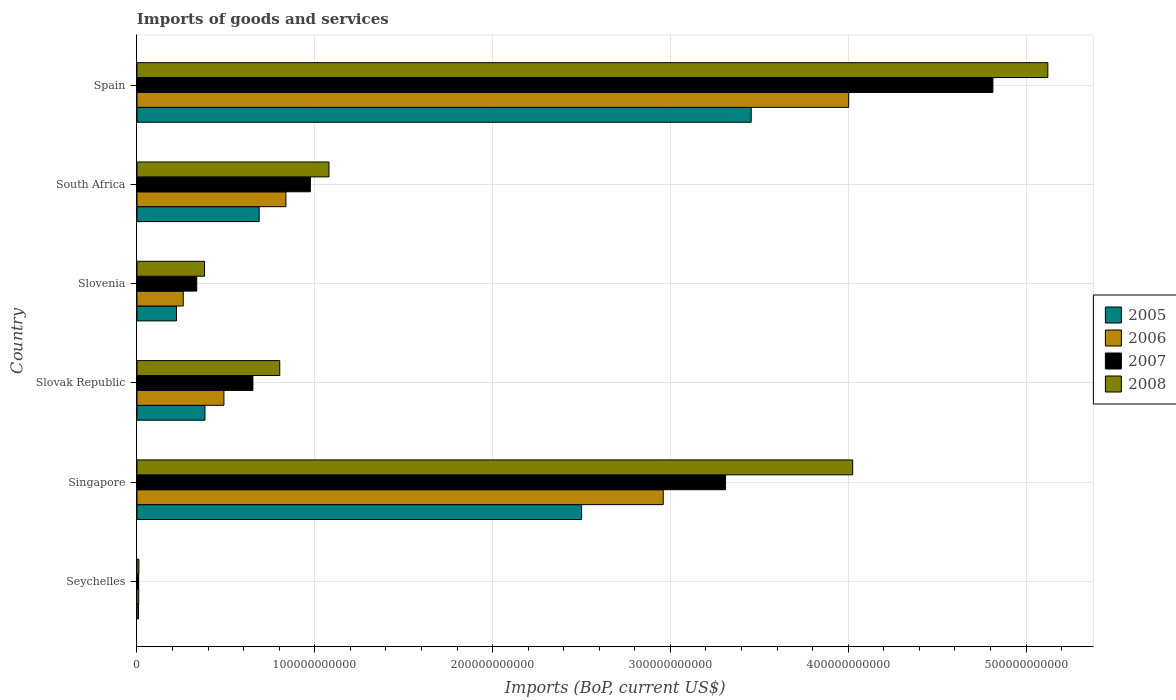How many bars are there on the 5th tick from the bottom?
Offer a very short reply. 4. What is the label of the 5th group of bars from the top?
Provide a succinct answer. Singapore. In how many cases, is the number of bars for a given country not equal to the number of legend labels?
Provide a succinct answer. 0. What is the amount spent on imports in 2005 in Singapore?
Provide a succinct answer. 2.50e+11. Across all countries, what is the maximum amount spent on imports in 2008?
Give a very brief answer. 5.12e+11. Across all countries, what is the minimum amount spent on imports in 2008?
Offer a terse response. 1.08e+09. In which country was the amount spent on imports in 2006 maximum?
Give a very brief answer. Spain. In which country was the amount spent on imports in 2005 minimum?
Provide a succinct answer. Seychelles. What is the total amount spent on imports in 2007 in the graph?
Offer a terse response. 1.01e+12. What is the difference between the amount spent on imports in 2006 in Seychelles and that in Slovak Republic?
Make the answer very short. -4.79e+1. What is the difference between the amount spent on imports in 2007 in Seychelles and the amount spent on imports in 2006 in Slovak Republic?
Keep it short and to the point. -4.80e+1. What is the average amount spent on imports in 2008 per country?
Your response must be concise. 1.90e+11. What is the difference between the amount spent on imports in 2006 and amount spent on imports in 2007 in Spain?
Offer a very short reply. -8.11e+1. What is the ratio of the amount spent on imports in 2005 in Singapore to that in Slovak Republic?
Your answer should be compact. 6.54. What is the difference between the highest and the second highest amount spent on imports in 2006?
Offer a very short reply. 1.04e+11. What is the difference between the highest and the lowest amount spent on imports in 2008?
Offer a very short reply. 5.11e+11. Is the sum of the amount spent on imports in 2007 in Slovak Republic and South Africa greater than the maximum amount spent on imports in 2005 across all countries?
Ensure brevity in your answer.  No. Is it the case that in every country, the sum of the amount spent on imports in 2005 and amount spent on imports in 2007 is greater than the sum of amount spent on imports in 2008 and amount spent on imports in 2006?
Ensure brevity in your answer.  No. What does the 1st bar from the top in Seychelles represents?
Ensure brevity in your answer.  2008. What does the 3rd bar from the bottom in Seychelles represents?
Ensure brevity in your answer.  2007. Is it the case that in every country, the sum of the amount spent on imports in 2007 and amount spent on imports in 2008 is greater than the amount spent on imports in 2005?
Your answer should be very brief. Yes. How many bars are there?
Keep it short and to the point. 24. Are all the bars in the graph horizontal?
Keep it short and to the point. Yes. How many countries are there in the graph?
Give a very brief answer. 6. What is the difference between two consecutive major ticks on the X-axis?
Provide a short and direct response. 1.00e+11. Does the graph contain any zero values?
Your response must be concise. No. Does the graph contain grids?
Provide a succinct answer. Yes. How many legend labels are there?
Give a very brief answer. 4. What is the title of the graph?
Provide a short and direct response. Imports of goods and services. What is the label or title of the X-axis?
Make the answer very short. Imports (BoP, current US$). What is the Imports (BoP, current US$) of 2005 in Seychelles?
Offer a very short reply. 8.85e+08. What is the Imports (BoP, current US$) in 2006 in Seychelles?
Provide a short and direct response. 9.85e+08. What is the Imports (BoP, current US$) in 2007 in Seychelles?
Ensure brevity in your answer.  9.49e+08. What is the Imports (BoP, current US$) in 2008 in Seychelles?
Ensure brevity in your answer.  1.08e+09. What is the Imports (BoP, current US$) of 2005 in Singapore?
Give a very brief answer. 2.50e+11. What is the Imports (BoP, current US$) of 2006 in Singapore?
Offer a very short reply. 2.96e+11. What is the Imports (BoP, current US$) of 2007 in Singapore?
Ensure brevity in your answer.  3.31e+11. What is the Imports (BoP, current US$) of 2008 in Singapore?
Offer a very short reply. 4.03e+11. What is the Imports (BoP, current US$) of 2005 in Slovak Republic?
Your answer should be compact. 3.82e+1. What is the Imports (BoP, current US$) in 2006 in Slovak Republic?
Keep it short and to the point. 4.89e+1. What is the Imports (BoP, current US$) in 2007 in Slovak Republic?
Offer a very short reply. 6.52e+1. What is the Imports (BoP, current US$) of 2008 in Slovak Republic?
Give a very brief answer. 8.03e+1. What is the Imports (BoP, current US$) in 2005 in Slovenia?
Make the answer very short. 2.22e+1. What is the Imports (BoP, current US$) of 2006 in Slovenia?
Your answer should be very brief. 2.60e+1. What is the Imports (BoP, current US$) in 2007 in Slovenia?
Your answer should be compact. 3.36e+1. What is the Imports (BoP, current US$) in 2008 in Slovenia?
Your answer should be very brief. 3.80e+1. What is the Imports (BoP, current US$) in 2005 in South Africa?
Make the answer very short. 6.87e+1. What is the Imports (BoP, current US$) in 2006 in South Africa?
Your answer should be compact. 8.38e+1. What is the Imports (BoP, current US$) in 2007 in South Africa?
Your response must be concise. 9.75e+1. What is the Imports (BoP, current US$) in 2008 in South Africa?
Make the answer very short. 1.08e+11. What is the Imports (BoP, current US$) in 2005 in Spain?
Your answer should be very brief. 3.45e+11. What is the Imports (BoP, current US$) of 2006 in Spain?
Make the answer very short. 4.00e+11. What is the Imports (BoP, current US$) of 2007 in Spain?
Ensure brevity in your answer.  4.81e+11. What is the Imports (BoP, current US$) in 2008 in Spain?
Your answer should be very brief. 5.12e+11. Across all countries, what is the maximum Imports (BoP, current US$) of 2005?
Make the answer very short. 3.45e+11. Across all countries, what is the maximum Imports (BoP, current US$) of 2006?
Give a very brief answer. 4.00e+11. Across all countries, what is the maximum Imports (BoP, current US$) of 2007?
Give a very brief answer. 4.81e+11. Across all countries, what is the maximum Imports (BoP, current US$) in 2008?
Give a very brief answer. 5.12e+11. Across all countries, what is the minimum Imports (BoP, current US$) of 2005?
Offer a very short reply. 8.85e+08. Across all countries, what is the minimum Imports (BoP, current US$) of 2006?
Offer a very short reply. 9.85e+08. Across all countries, what is the minimum Imports (BoP, current US$) of 2007?
Provide a short and direct response. 9.49e+08. Across all countries, what is the minimum Imports (BoP, current US$) in 2008?
Ensure brevity in your answer.  1.08e+09. What is the total Imports (BoP, current US$) in 2005 in the graph?
Provide a short and direct response. 7.26e+11. What is the total Imports (BoP, current US$) of 2006 in the graph?
Ensure brevity in your answer.  8.56e+11. What is the total Imports (BoP, current US$) in 2007 in the graph?
Your answer should be very brief. 1.01e+12. What is the total Imports (BoP, current US$) of 2008 in the graph?
Your answer should be very brief. 1.14e+12. What is the difference between the Imports (BoP, current US$) of 2005 in Seychelles and that in Singapore?
Your response must be concise. -2.49e+11. What is the difference between the Imports (BoP, current US$) in 2006 in Seychelles and that in Singapore?
Your answer should be very brief. -2.95e+11. What is the difference between the Imports (BoP, current US$) of 2007 in Seychelles and that in Singapore?
Offer a very short reply. -3.30e+11. What is the difference between the Imports (BoP, current US$) of 2008 in Seychelles and that in Singapore?
Keep it short and to the point. -4.01e+11. What is the difference between the Imports (BoP, current US$) in 2005 in Seychelles and that in Slovak Republic?
Make the answer very short. -3.74e+1. What is the difference between the Imports (BoP, current US$) in 2006 in Seychelles and that in Slovak Republic?
Your response must be concise. -4.79e+1. What is the difference between the Imports (BoP, current US$) in 2007 in Seychelles and that in Slovak Republic?
Ensure brevity in your answer.  -6.43e+1. What is the difference between the Imports (BoP, current US$) in 2008 in Seychelles and that in Slovak Republic?
Give a very brief answer. -7.92e+1. What is the difference between the Imports (BoP, current US$) in 2005 in Seychelles and that in Slovenia?
Give a very brief answer. -2.14e+1. What is the difference between the Imports (BoP, current US$) of 2006 in Seychelles and that in Slovenia?
Provide a short and direct response. -2.51e+1. What is the difference between the Imports (BoP, current US$) of 2007 in Seychelles and that in Slovenia?
Provide a succinct answer. -3.27e+1. What is the difference between the Imports (BoP, current US$) of 2008 in Seychelles and that in Slovenia?
Your response must be concise. -3.69e+1. What is the difference between the Imports (BoP, current US$) of 2005 in Seychelles and that in South Africa?
Your answer should be compact. -6.78e+1. What is the difference between the Imports (BoP, current US$) of 2006 in Seychelles and that in South Africa?
Your answer should be compact. -8.28e+1. What is the difference between the Imports (BoP, current US$) in 2007 in Seychelles and that in South Africa?
Your answer should be very brief. -9.66e+1. What is the difference between the Imports (BoP, current US$) in 2008 in Seychelles and that in South Africa?
Offer a very short reply. -1.07e+11. What is the difference between the Imports (BoP, current US$) in 2005 in Seychelles and that in Spain?
Your answer should be very brief. -3.45e+11. What is the difference between the Imports (BoP, current US$) in 2006 in Seychelles and that in Spain?
Your answer should be very brief. -3.99e+11. What is the difference between the Imports (BoP, current US$) of 2007 in Seychelles and that in Spain?
Your answer should be compact. -4.80e+11. What is the difference between the Imports (BoP, current US$) in 2008 in Seychelles and that in Spain?
Provide a short and direct response. -5.11e+11. What is the difference between the Imports (BoP, current US$) in 2005 in Singapore and that in Slovak Republic?
Your response must be concise. 2.12e+11. What is the difference between the Imports (BoP, current US$) in 2006 in Singapore and that in Slovak Republic?
Offer a very short reply. 2.47e+11. What is the difference between the Imports (BoP, current US$) in 2007 in Singapore and that in Slovak Republic?
Offer a terse response. 2.66e+11. What is the difference between the Imports (BoP, current US$) in 2008 in Singapore and that in Slovak Republic?
Your answer should be compact. 3.22e+11. What is the difference between the Imports (BoP, current US$) in 2005 in Singapore and that in Slovenia?
Your answer should be compact. 2.28e+11. What is the difference between the Imports (BoP, current US$) of 2006 in Singapore and that in Slovenia?
Give a very brief answer. 2.70e+11. What is the difference between the Imports (BoP, current US$) in 2007 in Singapore and that in Slovenia?
Provide a short and direct response. 2.97e+11. What is the difference between the Imports (BoP, current US$) in 2008 in Singapore and that in Slovenia?
Provide a succinct answer. 3.64e+11. What is the difference between the Imports (BoP, current US$) of 2005 in Singapore and that in South Africa?
Keep it short and to the point. 1.81e+11. What is the difference between the Imports (BoP, current US$) in 2006 in Singapore and that in South Africa?
Provide a succinct answer. 2.12e+11. What is the difference between the Imports (BoP, current US$) in 2007 in Singapore and that in South Africa?
Provide a succinct answer. 2.34e+11. What is the difference between the Imports (BoP, current US$) of 2008 in Singapore and that in South Africa?
Provide a succinct answer. 2.95e+11. What is the difference between the Imports (BoP, current US$) of 2005 in Singapore and that in Spain?
Provide a short and direct response. -9.54e+1. What is the difference between the Imports (BoP, current US$) of 2006 in Singapore and that in Spain?
Provide a short and direct response. -1.04e+11. What is the difference between the Imports (BoP, current US$) of 2007 in Singapore and that in Spain?
Your answer should be very brief. -1.50e+11. What is the difference between the Imports (BoP, current US$) of 2008 in Singapore and that in Spain?
Offer a very short reply. -1.10e+11. What is the difference between the Imports (BoP, current US$) of 2005 in Slovak Republic and that in Slovenia?
Your answer should be compact. 1.60e+1. What is the difference between the Imports (BoP, current US$) of 2006 in Slovak Republic and that in Slovenia?
Provide a succinct answer. 2.29e+1. What is the difference between the Imports (BoP, current US$) of 2007 in Slovak Republic and that in Slovenia?
Offer a terse response. 3.16e+1. What is the difference between the Imports (BoP, current US$) in 2008 in Slovak Republic and that in Slovenia?
Provide a succinct answer. 4.23e+1. What is the difference between the Imports (BoP, current US$) in 2005 in Slovak Republic and that in South Africa?
Your answer should be compact. -3.05e+1. What is the difference between the Imports (BoP, current US$) in 2006 in Slovak Republic and that in South Africa?
Your response must be concise. -3.49e+1. What is the difference between the Imports (BoP, current US$) of 2007 in Slovak Republic and that in South Africa?
Your response must be concise. -3.23e+1. What is the difference between the Imports (BoP, current US$) in 2008 in Slovak Republic and that in South Africa?
Ensure brevity in your answer.  -2.77e+1. What is the difference between the Imports (BoP, current US$) in 2005 in Slovak Republic and that in Spain?
Your response must be concise. -3.07e+11. What is the difference between the Imports (BoP, current US$) in 2006 in Slovak Republic and that in Spain?
Your answer should be very brief. -3.51e+11. What is the difference between the Imports (BoP, current US$) in 2007 in Slovak Republic and that in Spain?
Ensure brevity in your answer.  -4.16e+11. What is the difference between the Imports (BoP, current US$) in 2008 in Slovak Republic and that in Spain?
Make the answer very short. -4.32e+11. What is the difference between the Imports (BoP, current US$) in 2005 in Slovenia and that in South Africa?
Offer a terse response. -4.65e+1. What is the difference between the Imports (BoP, current US$) of 2006 in Slovenia and that in South Africa?
Ensure brevity in your answer.  -5.77e+1. What is the difference between the Imports (BoP, current US$) of 2007 in Slovenia and that in South Africa?
Keep it short and to the point. -6.39e+1. What is the difference between the Imports (BoP, current US$) of 2008 in Slovenia and that in South Africa?
Offer a very short reply. -7.00e+1. What is the difference between the Imports (BoP, current US$) in 2005 in Slovenia and that in Spain?
Keep it short and to the point. -3.23e+11. What is the difference between the Imports (BoP, current US$) in 2006 in Slovenia and that in Spain?
Your answer should be compact. -3.74e+11. What is the difference between the Imports (BoP, current US$) of 2007 in Slovenia and that in Spain?
Provide a succinct answer. -4.48e+11. What is the difference between the Imports (BoP, current US$) in 2008 in Slovenia and that in Spain?
Offer a terse response. -4.74e+11. What is the difference between the Imports (BoP, current US$) in 2005 in South Africa and that in Spain?
Give a very brief answer. -2.77e+11. What is the difference between the Imports (BoP, current US$) of 2006 in South Africa and that in Spain?
Your response must be concise. -3.16e+11. What is the difference between the Imports (BoP, current US$) in 2007 in South Africa and that in Spain?
Your answer should be compact. -3.84e+11. What is the difference between the Imports (BoP, current US$) of 2008 in South Africa and that in Spain?
Provide a short and direct response. -4.04e+11. What is the difference between the Imports (BoP, current US$) of 2005 in Seychelles and the Imports (BoP, current US$) of 2006 in Singapore?
Offer a very short reply. -2.95e+11. What is the difference between the Imports (BoP, current US$) of 2005 in Seychelles and the Imports (BoP, current US$) of 2007 in Singapore?
Offer a very short reply. -3.30e+11. What is the difference between the Imports (BoP, current US$) of 2005 in Seychelles and the Imports (BoP, current US$) of 2008 in Singapore?
Provide a short and direct response. -4.02e+11. What is the difference between the Imports (BoP, current US$) of 2006 in Seychelles and the Imports (BoP, current US$) of 2007 in Singapore?
Your answer should be very brief. -3.30e+11. What is the difference between the Imports (BoP, current US$) in 2006 in Seychelles and the Imports (BoP, current US$) in 2008 in Singapore?
Ensure brevity in your answer.  -4.02e+11. What is the difference between the Imports (BoP, current US$) in 2007 in Seychelles and the Imports (BoP, current US$) in 2008 in Singapore?
Provide a short and direct response. -4.02e+11. What is the difference between the Imports (BoP, current US$) in 2005 in Seychelles and the Imports (BoP, current US$) in 2006 in Slovak Republic?
Your response must be concise. -4.80e+1. What is the difference between the Imports (BoP, current US$) in 2005 in Seychelles and the Imports (BoP, current US$) in 2007 in Slovak Republic?
Make the answer very short. -6.43e+1. What is the difference between the Imports (BoP, current US$) in 2005 in Seychelles and the Imports (BoP, current US$) in 2008 in Slovak Republic?
Your response must be concise. -7.94e+1. What is the difference between the Imports (BoP, current US$) in 2006 in Seychelles and the Imports (BoP, current US$) in 2007 in Slovak Republic?
Give a very brief answer. -6.42e+1. What is the difference between the Imports (BoP, current US$) in 2006 in Seychelles and the Imports (BoP, current US$) in 2008 in Slovak Republic?
Give a very brief answer. -7.93e+1. What is the difference between the Imports (BoP, current US$) in 2007 in Seychelles and the Imports (BoP, current US$) in 2008 in Slovak Republic?
Give a very brief answer. -7.93e+1. What is the difference between the Imports (BoP, current US$) in 2005 in Seychelles and the Imports (BoP, current US$) in 2006 in Slovenia?
Provide a short and direct response. -2.52e+1. What is the difference between the Imports (BoP, current US$) of 2005 in Seychelles and the Imports (BoP, current US$) of 2007 in Slovenia?
Ensure brevity in your answer.  -3.27e+1. What is the difference between the Imports (BoP, current US$) in 2005 in Seychelles and the Imports (BoP, current US$) in 2008 in Slovenia?
Your answer should be very brief. -3.71e+1. What is the difference between the Imports (BoP, current US$) in 2006 in Seychelles and the Imports (BoP, current US$) in 2007 in Slovenia?
Make the answer very short. -3.26e+1. What is the difference between the Imports (BoP, current US$) of 2006 in Seychelles and the Imports (BoP, current US$) of 2008 in Slovenia?
Your response must be concise. -3.70e+1. What is the difference between the Imports (BoP, current US$) in 2007 in Seychelles and the Imports (BoP, current US$) in 2008 in Slovenia?
Make the answer very short. -3.71e+1. What is the difference between the Imports (BoP, current US$) of 2005 in Seychelles and the Imports (BoP, current US$) of 2006 in South Africa?
Ensure brevity in your answer.  -8.29e+1. What is the difference between the Imports (BoP, current US$) of 2005 in Seychelles and the Imports (BoP, current US$) of 2007 in South Africa?
Your answer should be compact. -9.66e+1. What is the difference between the Imports (BoP, current US$) of 2005 in Seychelles and the Imports (BoP, current US$) of 2008 in South Africa?
Offer a terse response. -1.07e+11. What is the difference between the Imports (BoP, current US$) in 2006 in Seychelles and the Imports (BoP, current US$) in 2007 in South Africa?
Your response must be concise. -9.65e+1. What is the difference between the Imports (BoP, current US$) in 2006 in Seychelles and the Imports (BoP, current US$) in 2008 in South Africa?
Keep it short and to the point. -1.07e+11. What is the difference between the Imports (BoP, current US$) in 2007 in Seychelles and the Imports (BoP, current US$) in 2008 in South Africa?
Offer a very short reply. -1.07e+11. What is the difference between the Imports (BoP, current US$) in 2005 in Seychelles and the Imports (BoP, current US$) in 2006 in Spain?
Offer a very short reply. -3.99e+11. What is the difference between the Imports (BoP, current US$) of 2005 in Seychelles and the Imports (BoP, current US$) of 2007 in Spain?
Make the answer very short. -4.80e+11. What is the difference between the Imports (BoP, current US$) in 2005 in Seychelles and the Imports (BoP, current US$) in 2008 in Spain?
Offer a terse response. -5.11e+11. What is the difference between the Imports (BoP, current US$) of 2006 in Seychelles and the Imports (BoP, current US$) of 2007 in Spain?
Make the answer very short. -4.80e+11. What is the difference between the Imports (BoP, current US$) in 2006 in Seychelles and the Imports (BoP, current US$) in 2008 in Spain?
Provide a succinct answer. -5.11e+11. What is the difference between the Imports (BoP, current US$) in 2007 in Seychelles and the Imports (BoP, current US$) in 2008 in Spain?
Your answer should be compact. -5.11e+11. What is the difference between the Imports (BoP, current US$) of 2005 in Singapore and the Imports (BoP, current US$) of 2006 in Slovak Republic?
Give a very brief answer. 2.01e+11. What is the difference between the Imports (BoP, current US$) of 2005 in Singapore and the Imports (BoP, current US$) of 2007 in Slovak Republic?
Your response must be concise. 1.85e+11. What is the difference between the Imports (BoP, current US$) in 2005 in Singapore and the Imports (BoP, current US$) in 2008 in Slovak Republic?
Offer a terse response. 1.70e+11. What is the difference between the Imports (BoP, current US$) of 2006 in Singapore and the Imports (BoP, current US$) of 2007 in Slovak Republic?
Offer a terse response. 2.31e+11. What is the difference between the Imports (BoP, current US$) in 2006 in Singapore and the Imports (BoP, current US$) in 2008 in Slovak Republic?
Offer a very short reply. 2.16e+11. What is the difference between the Imports (BoP, current US$) in 2007 in Singapore and the Imports (BoP, current US$) in 2008 in Slovak Republic?
Your response must be concise. 2.51e+11. What is the difference between the Imports (BoP, current US$) in 2005 in Singapore and the Imports (BoP, current US$) in 2006 in Slovenia?
Keep it short and to the point. 2.24e+11. What is the difference between the Imports (BoP, current US$) of 2005 in Singapore and the Imports (BoP, current US$) of 2007 in Slovenia?
Provide a short and direct response. 2.16e+11. What is the difference between the Imports (BoP, current US$) in 2005 in Singapore and the Imports (BoP, current US$) in 2008 in Slovenia?
Keep it short and to the point. 2.12e+11. What is the difference between the Imports (BoP, current US$) of 2006 in Singapore and the Imports (BoP, current US$) of 2007 in Slovenia?
Offer a terse response. 2.62e+11. What is the difference between the Imports (BoP, current US$) of 2006 in Singapore and the Imports (BoP, current US$) of 2008 in Slovenia?
Offer a terse response. 2.58e+11. What is the difference between the Imports (BoP, current US$) in 2007 in Singapore and the Imports (BoP, current US$) in 2008 in Slovenia?
Your response must be concise. 2.93e+11. What is the difference between the Imports (BoP, current US$) in 2005 in Singapore and the Imports (BoP, current US$) in 2006 in South Africa?
Offer a very short reply. 1.66e+11. What is the difference between the Imports (BoP, current US$) in 2005 in Singapore and the Imports (BoP, current US$) in 2007 in South Africa?
Offer a terse response. 1.53e+11. What is the difference between the Imports (BoP, current US$) in 2005 in Singapore and the Imports (BoP, current US$) in 2008 in South Africa?
Your response must be concise. 1.42e+11. What is the difference between the Imports (BoP, current US$) of 2006 in Singapore and the Imports (BoP, current US$) of 2007 in South Africa?
Offer a terse response. 1.98e+11. What is the difference between the Imports (BoP, current US$) of 2006 in Singapore and the Imports (BoP, current US$) of 2008 in South Africa?
Your answer should be compact. 1.88e+11. What is the difference between the Imports (BoP, current US$) in 2007 in Singapore and the Imports (BoP, current US$) in 2008 in South Africa?
Your answer should be very brief. 2.23e+11. What is the difference between the Imports (BoP, current US$) of 2005 in Singapore and the Imports (BoP, current US$) of 2006 in Spain?
Ensure brevity in your answer.  -1.50e+11. What is the difference between the Imports (BoP, current US$) in 2005 in Singapore and the Imports (BoP, current US$) in 2007 in Spain?
Provide a short and direct response. -2.31e+11. What is the difference between the Imports (BoP, current US$) of 2005 in Singapore and the Imports (BoP, current US$) of 2008 in Spain?
Give a very brief answer. -2.62e+11. What is the difference between the Imports (BoP, current US$) in 2006 in Singapore and the Imports (BoP, current US$) in 2007 in Spain?
Ensure brevity in your answer.  -1.85e+11. What is the difference between the Imports (BoP, current US$) of 2006 in Singapore and the Imports (BoP, current US$) of 2008 in Spain?
Give a very brief answer. -2.16e+11. What is the difference between the Imports (BoP, current US$) in 2007 in Singapore and the Imports (BoP, current US$) in 2008 in Spain?
Your response must be concise. -1.81e+11. What is the difference between the Imports (BoP, current US$) of 2005 in Slovak Republic and the Imports (BoP, current US$) of 2006 in Slovenia?
Provide a succinct answer. 1.22e+1. What is the difference between the Imports (BoP, current US$) in 2005 in Slovak Republic and the Imports (BoP, current US$) in 2007 in Slovenia?
Offer a very short reply. 4.62e+09. What is the difference between the Imports (BoP, current US$) of 2005 in Slovak Republic and the Imports (BoP, current US$) of 2008 in Slovenia?
Your answer should be very brief. 2.41e+08. What is the difference between the Imports (BoP, current US$) of 2006 in Slovak Republic and the Imports (BoP, current US$) of 2007 in Slovenia?
Give a very brief answer. 1.53e+1. What is the difference between the Imports (BoP, current US$) in 2006 in Slovak Republic and the Imports (BoP, current US$) in 2008 in Slovenia?
Your answer should be very brief. 1.09e+1. What is the difference between the Imports (BoP, current US$) in 2007 in Slovak Republic and the Imports (BoP, current US$) in 2008 in Slovenia?
Keep it short and to the point. 2.72e+1. What is the difference between the Imports (BoP, current US$) in 2005 in Slovak Republic and the Imports (BoP, current US$) in 2006 in South Africa?
Offer a terse response. -4.55e+1. What is the difference between the Imports (BoP, current US$) in 2005 in Slovak Republic and the Imports (BoP, current US$) in 2007 in South Africa?
Offer a very short reply. -5.93e+1. What is the difference between the Imports (BoP, current US$) in 2005 in Slovak Republic and the Imports (BoP, current US$) in 2008 in South Africa?
Offer a very short reply. -6.97e+1. What is the difference between the Imports (BoP, current US$) of 2006 in Slovak Republic and the Imports (BoP, current US$) of 2007 in South Africa?
Offer a very short reply. -4.86e+1. What is the difference between the Imports (BoP, current US$) in 2006 in Slovak Republic and the Imports (BoP, current US$) in 2008 in South Africa?
Give a very brief answer. -5.91e+1. What is the difference between the Imports (BoP, current US$) in 2007 in Slovak Republic and the Imports (BoP, current US$) in 2008 in South Africa?
Ensure brevity in your answer.  -4.28e+1. What is the difference between the Imports (BoP, current US$) in 2005 in Slovak Republic and the Imports (BoP, current US$) in 2006 in Spain?
Ensure brevity in your answer.  -3.62e+11. What is the difference between the Imports (BoP, current US$) in 2005 in Slovak Republic and the Imports (BoP, current US$) in 2007 in Spain?
Offer a very short reply. -4.43e+11. What is the difference between the Imports (BoP, current US$) of 2005 in Slovak Republic and the Imports (BoP, current US$) of 2008 in Spain?
Make the answer very short. -4.74e+11. What is the difference between the Imports (BoP, current US$) in 2006 in Slovak Republic and the Imports (BoP, current US$) in 2007 in Spain?
Offer a terse response. -4.32e+11. What is the difference between the Imports (BoP, current US$) of 2006 in Slovak Republic and the Imports (BoP, current US$) of 2008 in Spain?
Offer a terse response. -4.63e+11. What is the difference between the Imports (BoP, current US$) in 2007 in Slovak Republic and the Imports (BoP, current US$) in 2008 in Spain?
Offer a very short reply. -4.47e+11. What is the difference between the Imports (BoP, current US$) in 2005 in Slovenia and the Imports (BoP, current US$) in 2006 in South Africa?
Keep it short and to the point. -6.15e+1. What is the difference between the Imports (BoP, current US$) of 2005 in Slovenia and the Imports (BoP, current US$) of 2007 in South Africa?
Make the answer very short. -7.53e+1. What is the difference between the Imports (BoP, current US$) in 2005 in Slovenia and the Imports (BoP, current US$) in 2008 in South Africa?
Provide a succinct answer. -8.57e+1. What is the difference between the Imports (BoP, current US$) in 2006 in Slovenia and the Imports (BoP, current US$) in 2007 in South Africa?
Offer a very short reply. -7.15e+1. What is the difference between the Imports (BoP, current US$) of 2006 in Slovenia and the Imports (BoP, current US$) of 2008 in South Africa?
Offer a terse response. -8.19e+1. What is the difference between the Imports (BoP, current US$) in 2007 in Slovenia and the Imports (BoP, current US$) in 2008 in South Africa?
Your response must be concise. -7.43e+1. What is the difference between the Imports (BoP, current US$) in 2005 in Slovenia and the Imports (BoP, current US$) in 2006 in Spain?
Keep it short and to the point. -3.78e+11. What is the difference between the Imports (BoP, current US$) of 2005 in Slovenia and the Imports (BoP, current US$) of 2007 in Spain?
Provide a succinct answer. -4.59e+11. What is the difference between the Imports (BoP, current US$) in 2005 in Slovenia and the Imports (BoP, current US$) in 2008 in Spain?
Keep it short and to the point. -4.90e+11. What is the difference between the Imports (BoP, current US$) of 2006 in Slovenia and the Imports (BoP, current US$) of 2007 in Spain?
Provide a succinct answer. -4.55e+11. What is the difference between the Imports (BoP, current US$) of 2006 in Slovenia and the Imports (BoP, current US$) of 2008 in Spain?
Provide a short and direct response. -4.86e+11. What is the difference between the Imports (BoP, current US$) of 2007 in Slovenia and the Imports (BoP, current US$) of 2008 in Spain?
Provide a succinct answer. -4.79e+11. What is the difference between the Imports (BoP, current US$) of 2005 in South Africa and the Imports (BoP, current US$) of 2006 in Spain?
Give a very brief answer. -3.32e+11. What is the difference between the Imports (BoP, current US$) of 2005 in South Africa and the Imports (BoP, current US$) of 2007 in Spain?
Make the answer very short. -4.13e+11. What is the difference between the Imports (BoP, current US$) in 2005 in South Africa and the Imports (BoP, current US$) in 2008 in Spain?
Offer a very short reply. -4.44e+11. What is the difference between the Imports (BoP, current US$) in 2006 in South Africa and the Imports (BoP, current US$) in 2007 in Spain?
Your answer should be compact. -3.98e+11. What is the difference between the Imports (BoP, current US$) in 2006 in South Africa and the Imports (BoP, current US$) in 2008 in Spain?
Provide a succinct answer. -4.28e+11. What is the difference between the Imports (BoP, current US$) in 2007 in South Africa and the Imports (BoP, current US$) in 2008 in Spain?
Offer a terse response. -4.15e+11. What is the average Imports (BoP, current US$) in 2005 per country?
Give a very brief answer. 1.21e+11. What is the average Imports (BoP, current US$) in 2006 per country?
Ensure brevity in your answer.  1.43e+11. What is the average Imports (BoP, current US$) in 2007 per country?
Give a very brief answer. 1.68e+11. What is the average Imports (BoP, current US$) of 2008 per country?
Keep it short and to the point. 1.90e+11. What is the difference between the Imports (BoP, current US$) in 2005 and Imports (BoP, current US$) in 2006 in Seychelles?
Offer a very short reply. -9.96e+07. What is the difference between the Imports (BoP, current US$) in 2005 and Imports (BoP, current US$) in 2007 in Seychelles?
Your answer should be very brief. -6.38e+07. What is the difference between the Imports (BoP, current US$) of 2005 and Imports (BoP, current US$) of 2008 in Seychelles?
Provide a short and direct response. -1.99e+08. What is the difference between the Imports (BoP, current US$) of 2006 and Imports (BoP, current US$) of 2007 in Seychelles?
Ensure brevity in your answer.  3.58e+07. What is the difference between the Imports (BoP, current US$) of 2006 and Imports (BoP, current US$) of 2008 in Seychelles?
Offer a terse response. -9.99e+07. What is the difference between the Imports (BoP, current US$) in 2007 and Imports (BoP, current US$) in 2008 in Seychelles?
Make the answer very short. -1.36e+08. What is the difference between the Imports (BoP, current US$) of 2005 and Imports (BoP, current US$) of 2006 in Singapore?
Provide a short and direct response. -4.59e+1. What is the difference between the Imports (BoP, current US$) of 2005 and Imports (BoP, current US$) of 2007 in Singapore?
Ensure brevity in your answer.  -8.10e+1. What is the difference between the Imports (BoP, current US$) in 2005 and Imports (BoP, current US$) in 2008 in Singapore?
Provide a succinct answer. -1.52e+11. What is the difference between the Imports (BoP, current US$) of 2006 and Imports (BoP, current US$) of 2007 in Singapore?
Keep it short and to the point. -3.50e+1. What is the difference between the Imports (BoP, current US$) of 2006 and Imports (BoP, current US$) of 2008 in Singapore?
Offer a very short reply. -1.07e+11. What is the difference between the Imports (BoP, current US$) of 2007 and Imports (BoP, current US$) of 2008 in Singapore?
Keep it short and to the point. -7.15e+1. What is the difference between the Imports (BoP, current US$) in 2005 and Imports (BoP, current US$) in 2006 in Slovak Republic?
Your answer should be very brief. -1.07e+1. What is the difference between the Imports (BoP, current US$) of 2005 and Imports (BoP, current US$) of 2007 in Slovak Republic?
Your answer should be very brief. -2.70e+1. What is the difference between the Imports (BoP, current US$) in 2005 and Imports (BoP, current US$) in 2008 in Slovak Republic?
Your answer should be very brief. -4.20e+1. What is the difference between the Imports (BoP, current US$) in 2006 and Imports (BoP, current US$) in 2007 in Slovak Republic?
Give a very brief answer. -1.63e+1. What is the difference between the Imports (BoP, current US$) in 2006 and Imports (BoP, current US$) in 2008 in Slovak Republic?
Give a very brief answer. -3.14e+1. What is the difference between the Imports (BoP, current US$) of 2007 and Imports (BoP, current US$) of 2008 in Slovak Republic?
Offer a terse response. -1.51e+1. What is the difference between the Imports (BoP, current US$) of 2005 and Imports (BoP, current US$) of 2006 in Slovenia?
Offer a terse response. -3.79e+09. What is the difference between the Imports (BoP, current US$) in 2005 and Imports (BoP, current US$) in 2007 in Slovenia?
Offer a very short reply. -1.14e+1. What is the difference between the Imports (BoP, current US$) in 2005 and Imports (BoP, current US$) in 2008 in Slovenia?
Provide a short and direct response. -1.58e+1. What is the difference between the Imports (BoP, current US$) in 2006 and Imports (BoP, current US$) in 2007 in Slovenia?
Provide a short and direct response. -7.59e+09. What is the difference between the Imports (BoP, current US$) in 2006 and Imports (BoP, current US$) in 2008 in Slovenia?
Provide a short and direct response. -1.20e+1. What is the difference between the Imports (BoP, current US$) in 2007 and Imports (BoP, current US$) in 2008 in Slovenia?
Provide a short and direct response. -4.38e+09. What is the difference between the Imports (BoP, current US$) in 2005 and Imports (BoP, current US$) in 2006 in South Africa?
Offer a very short reply. -1.50e+1. What is the difference between the Imports (BoP, current US$) of 2005 and Imports (BoP, current US$) of 2007 in South Africa?
Your response must be concise. -2.88e+1. What is the difference between the Imports (BoP, current US$) in 2005 and Imports (BoP, current US$) in 2008 in South Africa?
Ensure brevity in your answer.  -3.93e+1. What is the difference between the Imports (BoP, current US$) in 2006 and Imports (BoP, current US$) in 2007 in South Africa?
Offer a very short reply. -1.37e+1. What is the difference between the Imports (BoP, current US$) of 2006 and Imports (BoP, current US$) of 2008 in South Africa?
Give a very brief answer. -2.42e+1. What is the difference between the Imports (BoP, current US$) in 2007 and Imports (BoP, current US$) in 2008 in South Africa?
Provide a short and direct response. -1.05e+1. What is the difference between the Imports (BoP, current US$) of 2005 and Imports (BoP, current US$) of 2006 in Spain?
Keep it short and to the point. -5.48e+1. What is the difference between the Imports (BoP, current US$) of 2005 and Imports (BoP, current US$) of 2007 in Spain?
Provide a succinct answer. -1.36e+11. What is the difference between the Imports (BoP, current US$) in 2005 and Imports (BoP, current US$) in 2008 in Spain?
Give a very brief answer. -1.67e+11. What is the difference between the Imports (BoP, current US$) in 2006 and Imports (BoP, current US$) in 2007 in Spain?
Give a very brief answer. -8.11e+1. What is the difference between the Imports (BoP, current US$) in 2006 and Imports (BoP, current US$) in 2008 in Spain?
Ensure brevity in your answer.  -1.12e+11. What is the difference between the Imports (BoP, current US$) in 2007 and Imports (BoP, current US$) in 2008 in Spain?
Give a very brief answer. -3.09e+1. What is the ratio of the Imports (BoP, current US$) of 2005 in Seychelles to that in Singapore?
Give a very brief answer. 0. What is the ratio of the Imports (BoP, current US$) of 2006 in Seychelles to that in Singapore?
Your answer should be very brief. 0. What is the ratio of the Imports (BoP, current US$) of 2007 in Seychelles to that in Singapore?
Your response must be concise. 0. What is the ratio of the Imports (BoP, current US$) of 2008 in Seychelles to that in Singapore?
Your answer should be compact. 0. What is the ratio of the Imports (BoP, current US$) of 2005 in Seychelles to that in Slovak Republic?
Ensure brevity in your answer.  0.02. What is the ratio of the Imports (BoP, current US$) in 2006 in Seychelles to that in Slovak Republic?
Offer a very short reply. 0.02. What is the ratio of the Imports (BoP, current US$) of 2007 in Seychelles to that in Slovak Republic?
Ensure brevity in your answer.  0.01. What is the ratio of the Imports (BoP, current US$) of 2008 in Seychelles to that in Slovak Republic?
Make the answer very short. 0.01. What is the ratio of the Imports (BoP, current US$) of 2005 in Seychelles to that in Slovenia?
Give a very brief answer. 0.04. What is the ratio of the Imports (BoP, current US$) in 2006 in Seychelles to that in Slovenia?
Provide a short and direct response. 0.04. What is the ratio of the Imports (BoP, current US$) of 2007 in Seychelles to that in Slovenia?
Make the answer very short. 0.03. What is the ratio of the Imports (BoP, current US$) of 2008 in Seychelles to that in Slovenia?
Make the answer very short. 0.03. What is the ratio of the Imports (BoP, current US$) of 2005 in Seychelles to that in South Africa?
Keep it short and to the point. 0.01. What is the ratio of the Imports (BoP, current US$) of 2006 in Seychelles to that in South Africa?
Provide a short and direct response. 0.01. What is the ratio of the Imports (BoP, current US$) in 2007 in Seychelles to that in South Africa?
Your response must be concise. 0.01. What is the ratio of the Imports (BoP, current US$) in 2005 in Seychelles to that in Spain?
Make the answer very short. 0. What is the ratio of the Imports (BoP, current US$) in 2006 in Seychelles to that in Spain?
Make the answer very short. 0. What is the ratio of the Imports (BoP, current US$) of 2007 in Seychelles to that in Spain?
Keep it short and to the point. 0. What is the ratio of the Imports (BoP, current US$) in 2008 in Seychelles to that in Spain?
Your response must be concise. 0. What is the ratio of the Imports (BoP, current US$) in 2005 in Singapore to that in Slovak Republic?
Offer a very short reply. 6.54. What is the ratio of the Imports (BoP, current US$) in 2006 in Singapore to that in Slovak Republic?
Ensure brevity in your answer.  6.05. What is the ratio of the Imports (BoP, current US$) in 2007 in Singapore to that in Slovak Republic?
Provide a short and direct response. 5.08. What is the ratio of the Imports (BoP, current US$) of 2008 in Singapore to that in Slovak Republic?
Your answer should be very brief. 5.01. What is the ratio of the Imports (BoP, current US$) of 2005 in Singapore to that in Slovenia?
Your response must be concise. 11.24. What is the ratio of the Imports (BoP, current US$) in 2006 in Singapore to that in Slovenia?
Provide a succinct answer. 11.37. What is the ratio of the Imports (BoP, current US$) in 2007 in Singapore to that in Slovenia?
Provide a short and direct response. 9.84. What is the ratio of the Imports (BoP, current US$) of 2008 in Singapore to that in Slovenia?
Offer a very short reply. 10.59. What is the ratio of the Imports (BoP, current US$) of 2005 in Singapore to that in South Africa?
Offer a very short reply. 3.64. What is the ratio of the Imports (BoP, current US$) in 2006 in Singapore to that in South Africa?
Provide a short and direct response. 3.53. What is the ratio of the Imports (BoP, current US$) in 2007 in Singapore to that in South Africa?
Offer a terse response. 3.39. What is the ratio of the Imports (BoP, current US$) of 2008 in Singapore to that in South Africa?
Offer a terse response. 3.73. What is the ratio of the Imports (BoP, current US$) of 2005 in Singapore to that in Spain?
Provide a succinct answer. 0.72. What is the ratio of the Imports (BoP, current US$) of 2006 in Singapore to that in Spain?
Offer a very short reply. 0.74. What is the ratio of the Imports (BoP, current US$) of 2007 in Singapore to that in Spain?
Ensure brevity in your answer.  0.69. What is the ratio of the Imports (BoP, current US$) of 2008 in Singapore to that in Spain?
Ensure brevity in your answer.  0.79. What is the ratio of the Imports (BoP, current US$) of 2005 in Slovak Republic to that in Slovenia?
Provide a short and direct response. 1.72. What is the ratio of the Imports (BoP, current US$) of 2006 in Slovak Republic to that in Slovenia?
Provide a succinct answer. 1.88. What is the ratio of the Imports (BoP, current US$) of 2007 in Slovak Republic to that in Slovenia?
Give a very brief answer. 1.94. What is the ratio of the Imports (BoP, current US$) in 2008 in Slovak Republic to that in Slovenia?
Provide a succinct answer. 2.11. What is the ratio of the Imports (BoP, current US$) of 2005 in Slovak Republic to that in South Africa?
Make the answer very short. 0.56. What is the ratio of the Imports (BoP, current US$) in 2006 in Slovak Republic to that in South Africa?
Offer a very short reply. 0.58. What is the ratio of the Imports (BoP, current US$) of 2007 in Slovak Republic to that in South Africa?
Offer a terse response. 0.67. What is the ratio of the Imports (BoP, current US$) in 2008 in Slovak Republic to that in South Africa?
Your response must be concise. 0.74. What is the ratio of the Imports (BoP, current US$) of 2005 in Slovak Republic to that in Spain?
Offer a terse response. 0.11. What is the ratio of the Imports (BoP, current US$) of 2006 in Slovak Republic to that in Spain?
Offer a terse response. 0.12. What is the ratio of the Imports (BoP, current US$) of 2007 in Slovak Republic to that in Spain?
Your answer should be compact. 0.14. What is the ratio of the Imports (BoP, current US$) of 2008 in Slovak Republic to that in Spain?
Give a very brief answer. 0.16. What is the ratio of the Imports (BoP, current US$) of 2005 in Slovenia to that in South Africa?
Your answer should be compact. 0.32. What is the ratio of the Imports (BoP, current US$) of 2006 in Slovenia to that in South Africa?
Provide a short and direct response. 0.31. What is the ratio of the Imports (BoP, current US$) in 2007 in Slovenia to that in South Africa?
Give a very brief answer. 0.34. What is the ratio of the Imports (BoP, current US$) of 2008 in Slovenia to that in South Africa?
Your answer should be compact. 0.35. What is the ratio of the Imports (BoP, current US$) in 2005 in Slovenia to that in Spain?
Keep it short and to the point. 0.06. What is the ratio of the Imports (BoP, current US$) of 2006 in Slovenia to that in Spain?
Ensure brevity in your answer.  0.07. What is the ratio of the Imports (BoP, current US$) in 2007 in Slovenia to that in Spain?
Your response must be concise. 0.07. What is the ratio of the Imports (BoP, current US$) of 2008 in Slovenia to that in Spain?
Offer a very short reply. 0.07. What is the ratio of the Imports (BoP, current US$) in 2005 in South Africa to that in Spain?
Your answer should be very brief. 0.2. What is the ratio of the Imports (BoP, current US$) in 2006 in South Africa to that in Spain?
Offer a terse response. 0.21. What is the ratio of the Imports (BoP, current US$) of 2007 in South Africa to that in Spain?
Your answer should be very brief. 0.2. What is the ratio of the Imports (BoP, current US$) of 2008 in South Africa to that in Spain?
Your answer should be compact. 0.21. What is the difference between the highest and the second highest Imports (BoP, current US$) in 2005?
Provide a succinct answer. 9.54e+1. What is the difference between the highest and the second highest Imports (BoP, current US$) of 2006?
Ensure brevity in your answer.  1.04e+11. What is the difference between the highest and the second highest Imports (BoP, current US$) of 2007?
Offer a terse response. 1.50e+11. What is the difference between the highest and the second highest Imports (BoP, current US$) of 2008?
Your answer should be very brief. 1.10e+11. What is the difference between the highest and the lowest Imports (BoP, current US$) in 2005?
Provide a succinct answer. 3.45e+11. What is the difference between the highest and the lowest Imports (BoP, current US$) in 2006?
Make the answer very short. 3.99e+11. What is the difference between the highest and the lowest Imports (BoP, current US$) in 2007?
Offer a terse response. 4.80e+11. What is the difference between the highest and the lowest Imports (BoP, current US$) in 2008?
Offer a very short reply. 5.11e+11. 